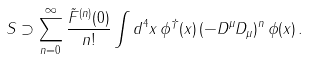<formula> <loc_0><loc_0><loc_500><loc_500>S \supset \sum _ { n = 0 } ^ { \infty } \frac { \tilde { F } ^ { ( n ) } ( 0 ) } { n ! } \int d ^ { 4 } x \, \phi ^ { \dagger } ( x ) \, ( - D ^ { \mu } D _ { \mu } ) ^ { n } \, \phi ( x ) \, .</formula> 